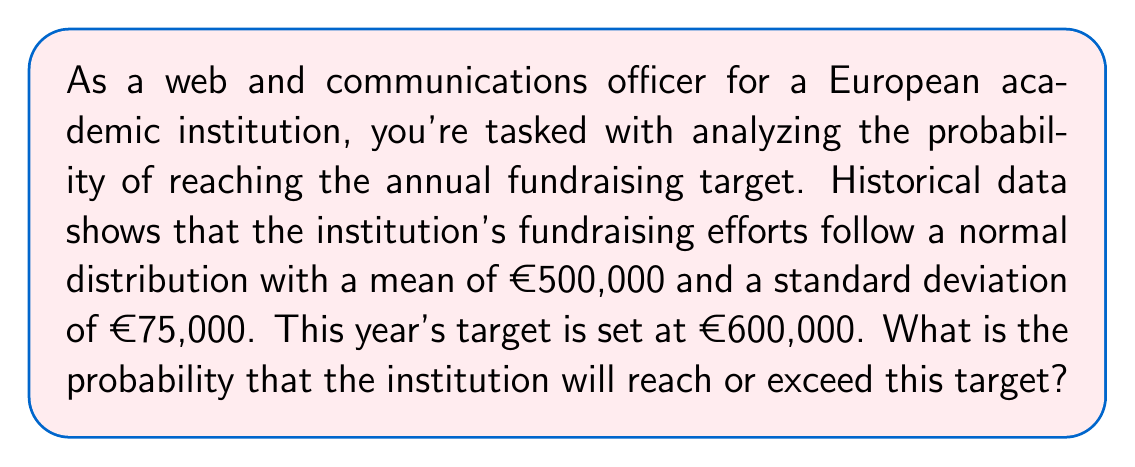Can you answer this question? To solve this problem, we need to use the properties of the normal distribution and calculate the z-score for the target amount. Then, we'll use the standard normal distribution table or a statistical function to find the probability.

Steps:

1. Identify the given information:
   - Mean (μ) = €500,000
   - Standard deviation (σ) = €75,000
   - Target amount = €600,000

2. Calculate the z-score for the target amount:
   $$ z = \frac{x - \mu}{\sigma} $$
   Where x is the target amount, μ is the mean, and σ is the standard deviation.

   $$ z = \frac{600,000 - 500,000}{75,000} = \frac{100,000}{75,000} = 1.33 $$

3. The probability we're looking for is the area under the normal curve to the right of z = 1.33. This is equal to 1 minus the cumulative probability up to z = 1.33.

4. Using a standard normal distribution table or a statistical function (like NORM.S.DIST in Excel or scipy.stats.norm.cdf in Python), we can find that the cumulative probability up to z = 1.33 is approximately 0.9082.

5. Therefore, the probability of reaching or exceeding the target is:
   $$ P(X \geq 600,000) = 1 - 0.9082 = 0.0918 $$

This means there's approximately a 9.18% chance of reaching or exceeding the fundraising target of €600,000.
Answer: The probability that the institution will reach or exceed the fundraising target of €600,000 is approximately 0.0918 or 9.18%. 